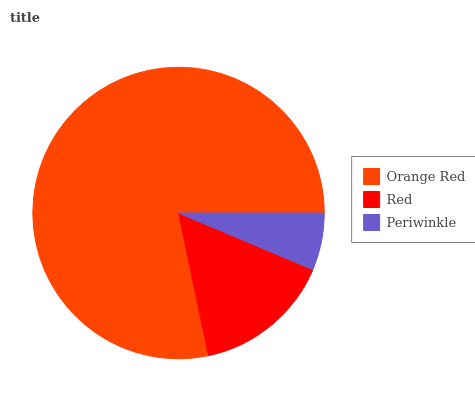Is Periwinkle the minimum?
Answer yes or no. Yes. Is Orange Red the maximum?
Answer yes or no. Yes. Is Red the minimum?
Answer yes or no. No. Is Red the maximum?
Answer yes or no. No. Is Orange Red greater than Red?
Answer yes or no. Yes. Is Red less than Orange Red?
Answer yes or no. Yes. Is Red greater than Orange Red?
Answer yes or no. No. Is Orange Red less than Red?
Answer yes or no. No. Is Red the high median?
Answer yes or no. Yes. Is Red the low median?
Answer yes or no. Yes. Is Periwinkle the high median?
Answer yes or no. No. Is Periwinkle the low median?
Answer yes or no. No. 